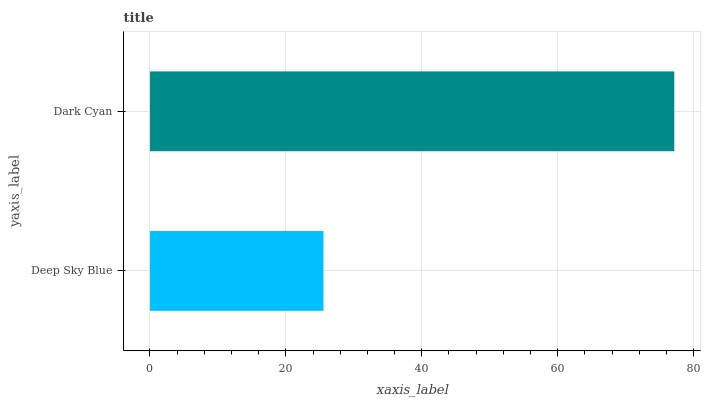Is Deep Sky Blue the minimum?
Answer yes or no. Yes. Is Dark Cyan the maximum?
Answer yes or no. Yes. Is Dark Cyan the minimum?
Answer yes or no. No. Is Dark Cyan greater than Deep Sky Blue?
Answer yes or no. Yes. Is Deep Sky Blue less than Dark Cyan?
Answer yes or no. Yes. Is Deep Sky Blue greater than Dark Cyan?
Answer yes or no. No. Is Dark Cyan less than Deep Sky Blue?
Answer yes or no. No. Is Dark Cyan the high median?
Answer yes or no. Yes. Is Deep Sky Blue the low median?
Answer yes or no. Yes. Is Deep Sky Blue the high median?
Answer yes or no. No. Is Dark Cyan the low median?
Answer yes or no. No. 